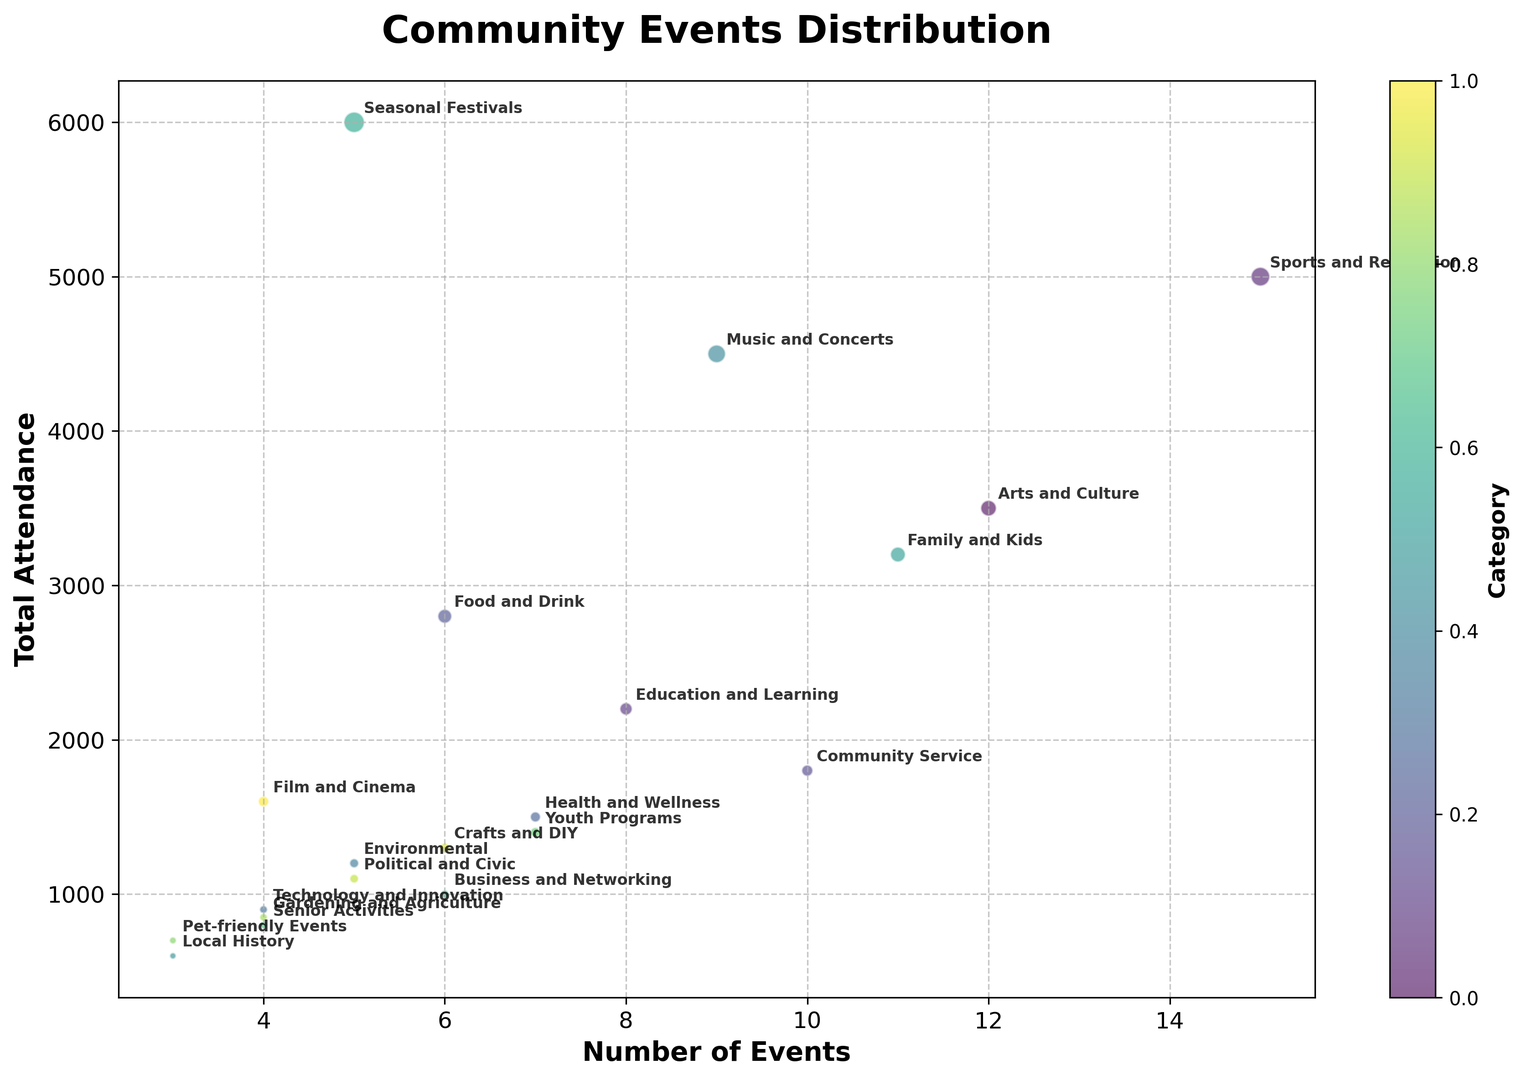Which category has the highest total attendance? From the bubble chart, the category with the highest y-value indicates the highest total attendance. "Seasonal Festivals" is positioned at the top with an attendance of 6000.
Answer: Seasonal Festivals Which category had the most events organized? The x-axis represents the number of events. The highest value on the x-axis belongs to "Sports and Recreation" with 15 events.
Answer: Sports and Recreation What is the total attendance for events in the "Arts and Culture" and "Music and Concerts" categories combined? The attendance for "Arts and Culture" is 3500 and for "Music and Concerts" is 4500. Adding these together: 3500 + 4500 = 8000.
Answer: 8000 Which category has a higher attendance: "Family and Kids" or "Technology and Innovation"? Referring to the y-axis, "Family and Kids" has an attendance of 3200, while "Technology and Innovation" has 900. Hence, "Family and Kids" has a higher attendance.
Answer: Family and Kids Which category has both the fewest events and the lowest total attendance? The bottom left bubble indicates this category, which is "Local History" with 3 events and 600 total attendance.
Answer: Local History How many categories have more than 3000 in total attendance and more than 10 events? From the chart, "Arts and Culture," "Sports and Recreation," "Family and Kids," and "Music and Concerts" meet the criteria. That's four categories.
Answer: 4 What's the median number of events organized across all categories? To find the median for the 'Events' column: the values are sorted as follows (3, 3, 4, 4, 4, 5, 5, 5, 6, 6, 6, 7, 7, 8, 9, 10, 11, 12, 15). The median value in this set is the 10th value, which is 6.
Answer: 6 How does the attendance of "Health and Wellness" compare to "Community Service"? From the graph, "Health and Wellness" has an attendance of 1500, while "Community Service" has 1800. "Community Service" has a higher attendance.
Answer: Community Service How many categories have an attendance between 1000 and 2000? The categories "Technology and Innovation," "Senior Activities," "Political and Civic," "Crafts and DIY," "Film and Cinema," and "Health and Wellness" all fall within this range, totaling six categories.
Answer: 6 